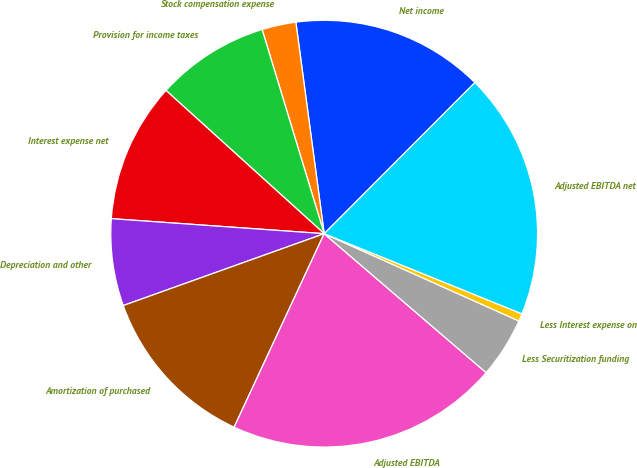Convert chart to OTSL. <chart><loc_0><loc_0><loc_500><loc_500><pie_chart><fcel>Net income<fcel>Stock compensation expense<fcel>Provision for income taxes<fcel>Interest expense net<fcel>Depreciation and other<fcel>Amortization of purchased<fcel>Adjusted EBITDA<fcel>Less Securitization funding<fcel>Less Interest expense on<fcel>Adjusted EBITDA net<nl><fcel>14.6%<fcel>2.58%<fcel>8.59%<fcel>10.59%<fcel>6.59%<fcel>12.6%<fcel>20.65%<fcel>4.58%<fcel>0.58%<fcel>18.65%<nl></chart> 